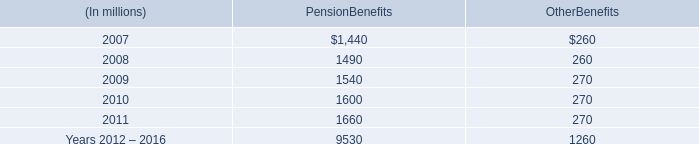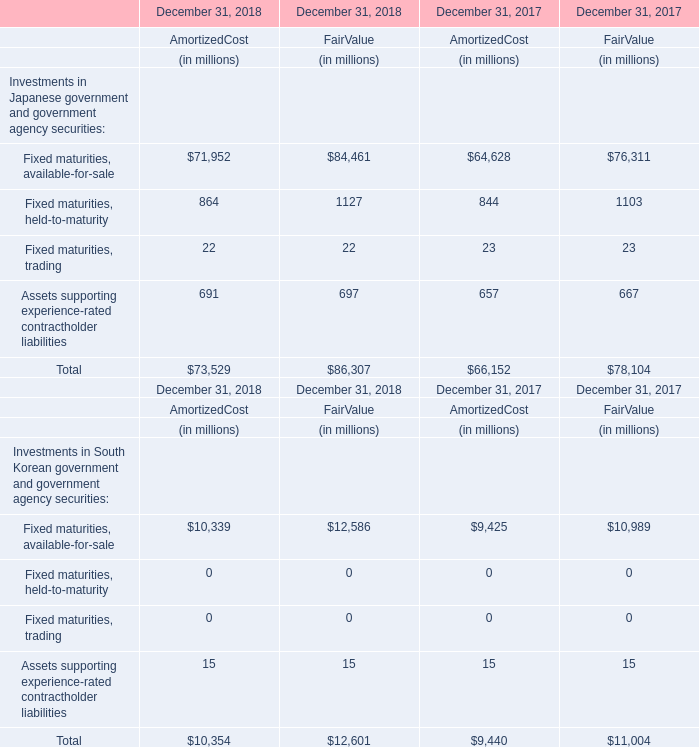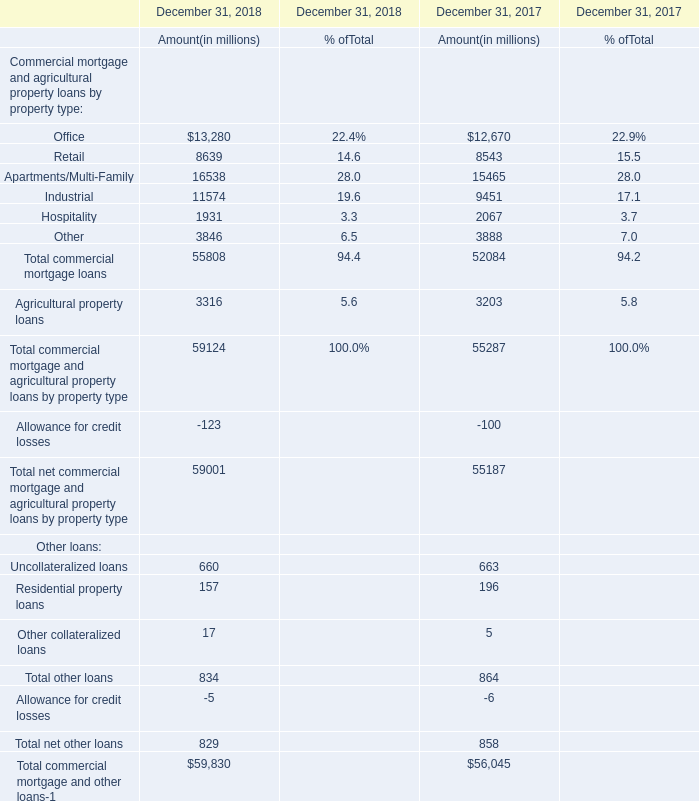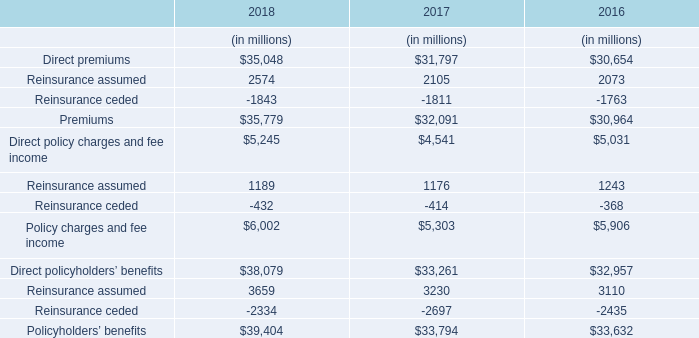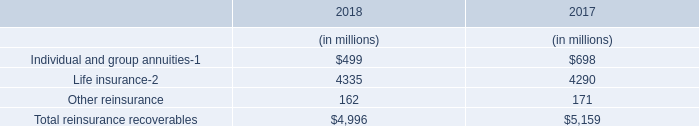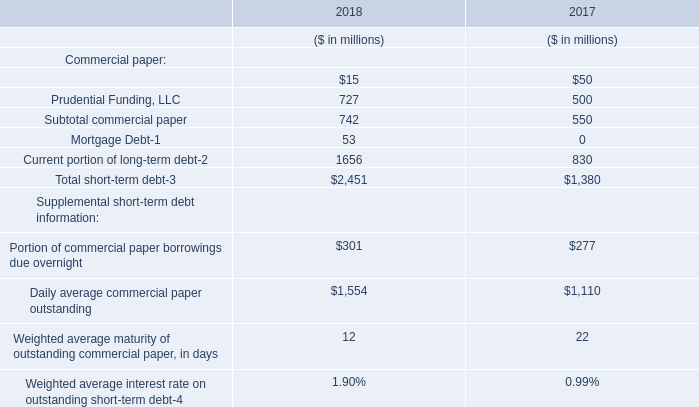what was the percentage change in the rental expense under operating leases from 2004 to 2005 
Computations: ((324 - 318) / 318)
Answer: 0.01887. 